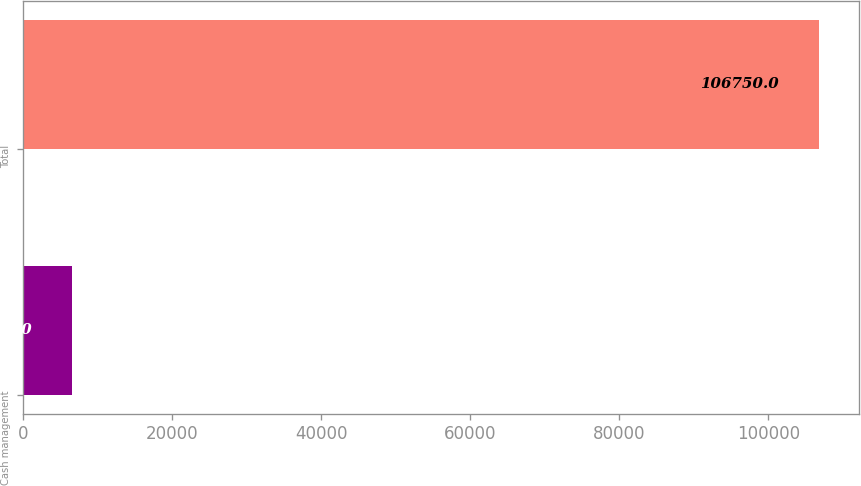Convert chart. <chart><loc_0><loc_0><loc_500><loc_500><bar_chart><fcel>Cash management<fcel>Total<nl><fcel>6593<fcel>106750<nl></chart> 